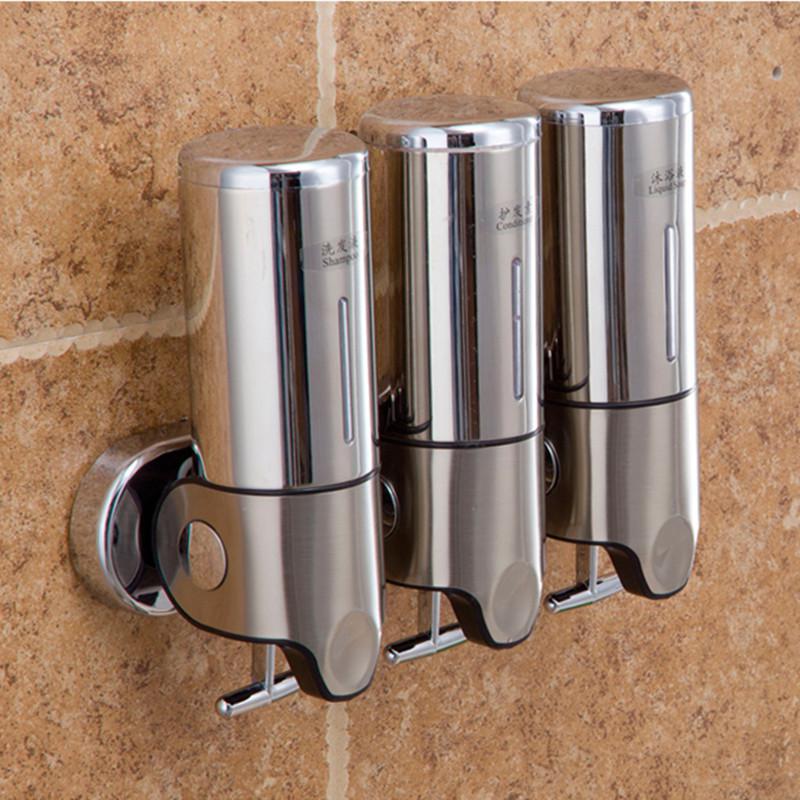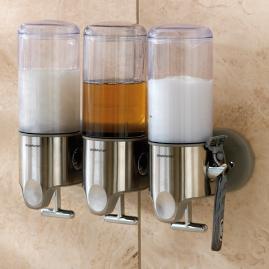The first image is the image on the left, the second image is the image on the right. For the images displayed, is the sentence "The image to the right features three soap dispensers." factually correct? Answer yes or no. Yes. The first image is the image on the left, the second image is the image on the right. Given the left and right images, does the statement "Both images contain three liquid bathroom product dispensers." hold true? Answer yes or no. Yes. 